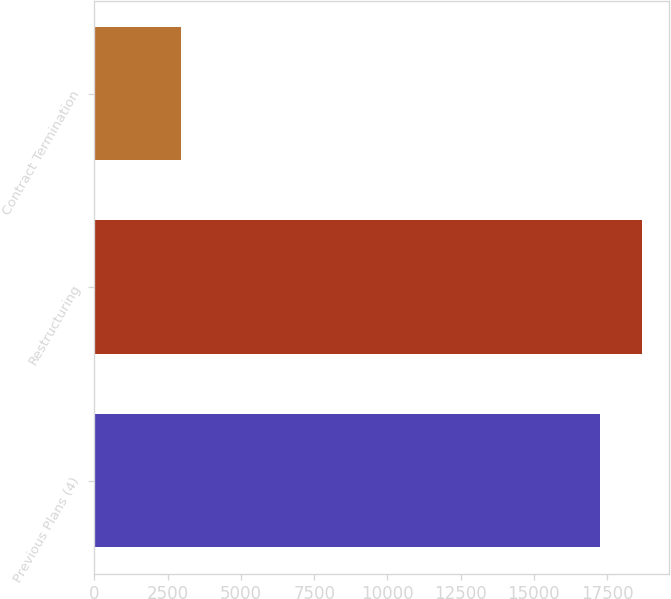<chart> <loc_0><loc_0><loc_500><loc_500><bar_chart><fcel>Previous Plans (4)<fcel>Restructuring<fcel>Contract Termination<nl><fcel>17249<fcel>18679.8<fcel>2941<nl></chart> 